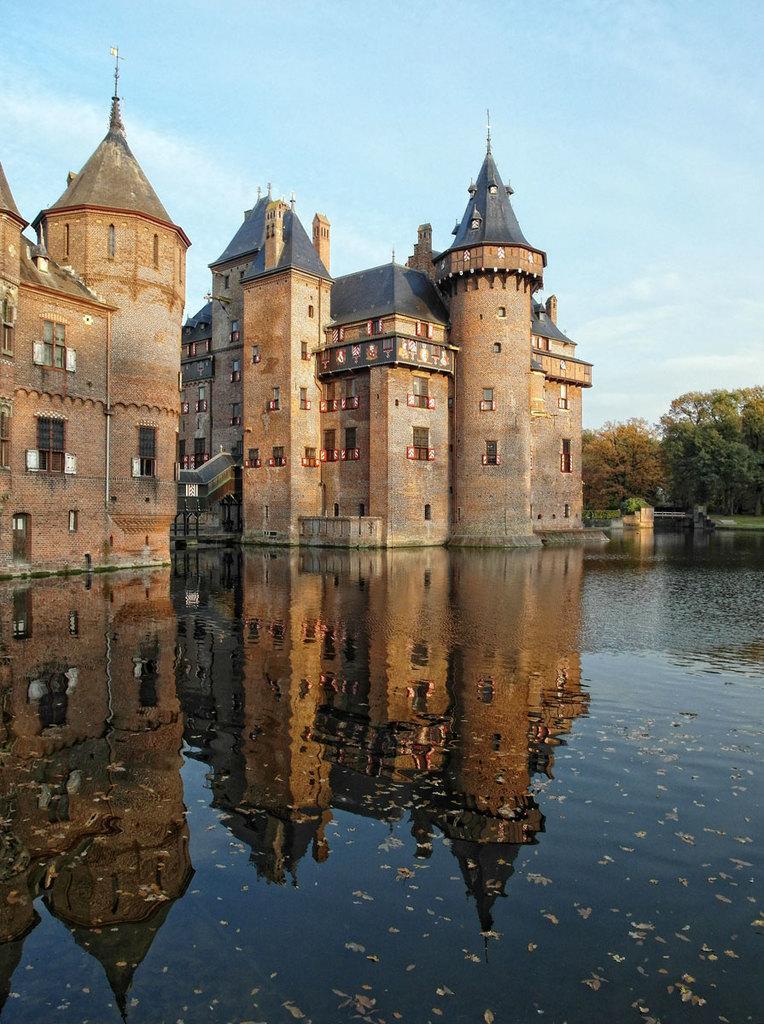Describe this image in one or two sentences. These are the buildings, at the down side there is water. On the right side there are trees, at the top it is the sky. 